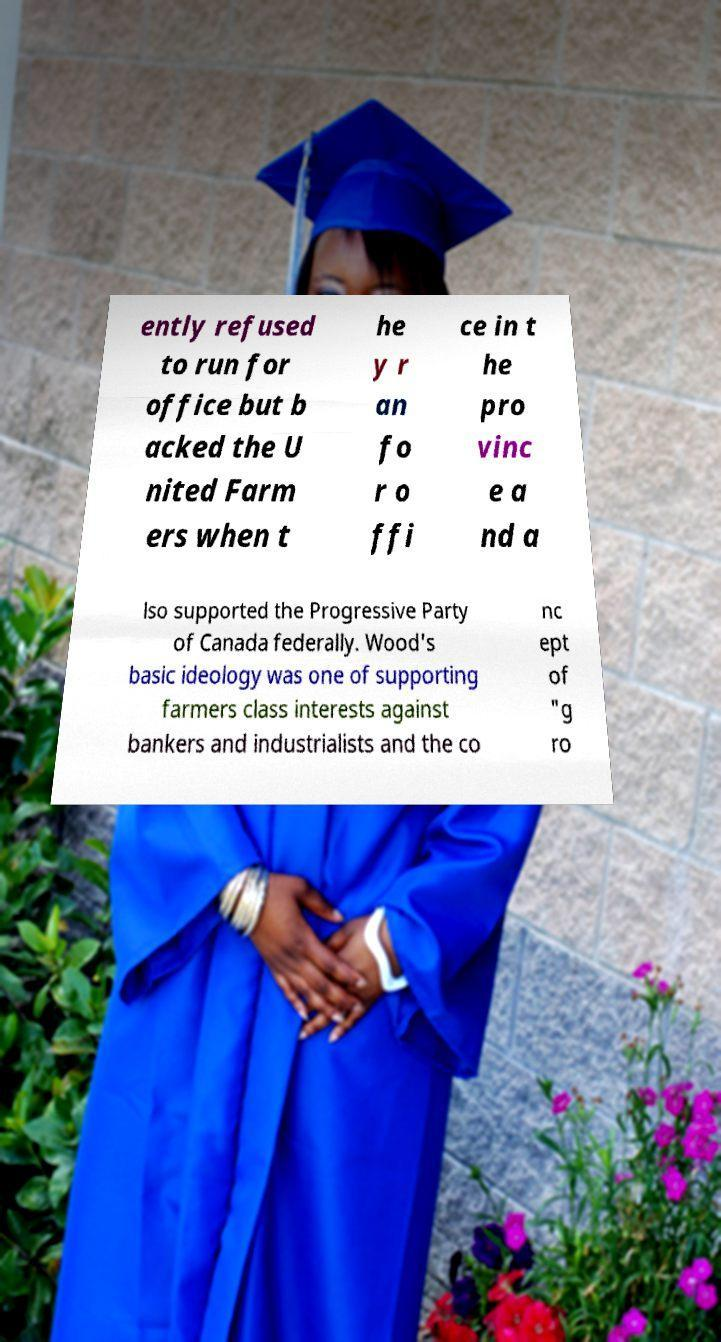What messages or text are displayed in this image? I need them in a readable, typed format. ently refused to run for office but b acked the U nited Farm ers when t he y r an fo r o ffi ce in t he pro vinc e a nd a lso supported the Progressive Party of Canada federally. Wood's basic ideology was one of supporting farmers class interests against bankers and industrialists and the co nc ept of "g ro 